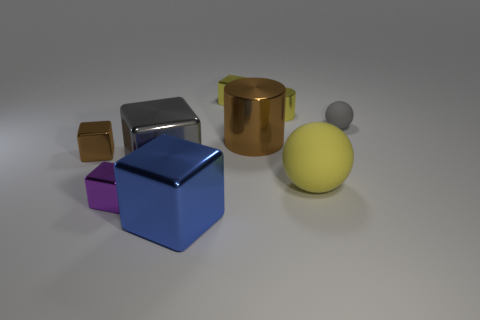Are there any small gray rubber spheres left of the large blue metallic object?
Provide a short and direct response. No. What number of small balls have the same material as the purple cube?
Offer a very short reply. 0. How many objects are either cyan matte cylinders or brown metallic blocks?
Make the answer very short. 1. Are any tiny red things visible?
Ensure brevity in your answer.  No. There is a large object on the right side of the small yellow shiny object in front of the yellow shiny cube right of the small purple metal object; what is its material?
Your answer should be compact. Rubber. Are there fewer yellow shiny blocks that are to the left of the yellow cube than small brown matte objects?
Your answer should be very brief. No. What material is the gray sphere that is the same size as the brown cube?
Make the answer very short. Rubber. How big is the block that is both behind the gray metallic object and on the right side of the small purple cube?
Your response must be concise. Small. What size is the blue object that is the same shape as the tiny brown metallic object?
Offer a terse response. Large. How many objects are blue metal blocks or small yellow shiny things that are in front of the yellow cube?
Offer a terse response. 2. 